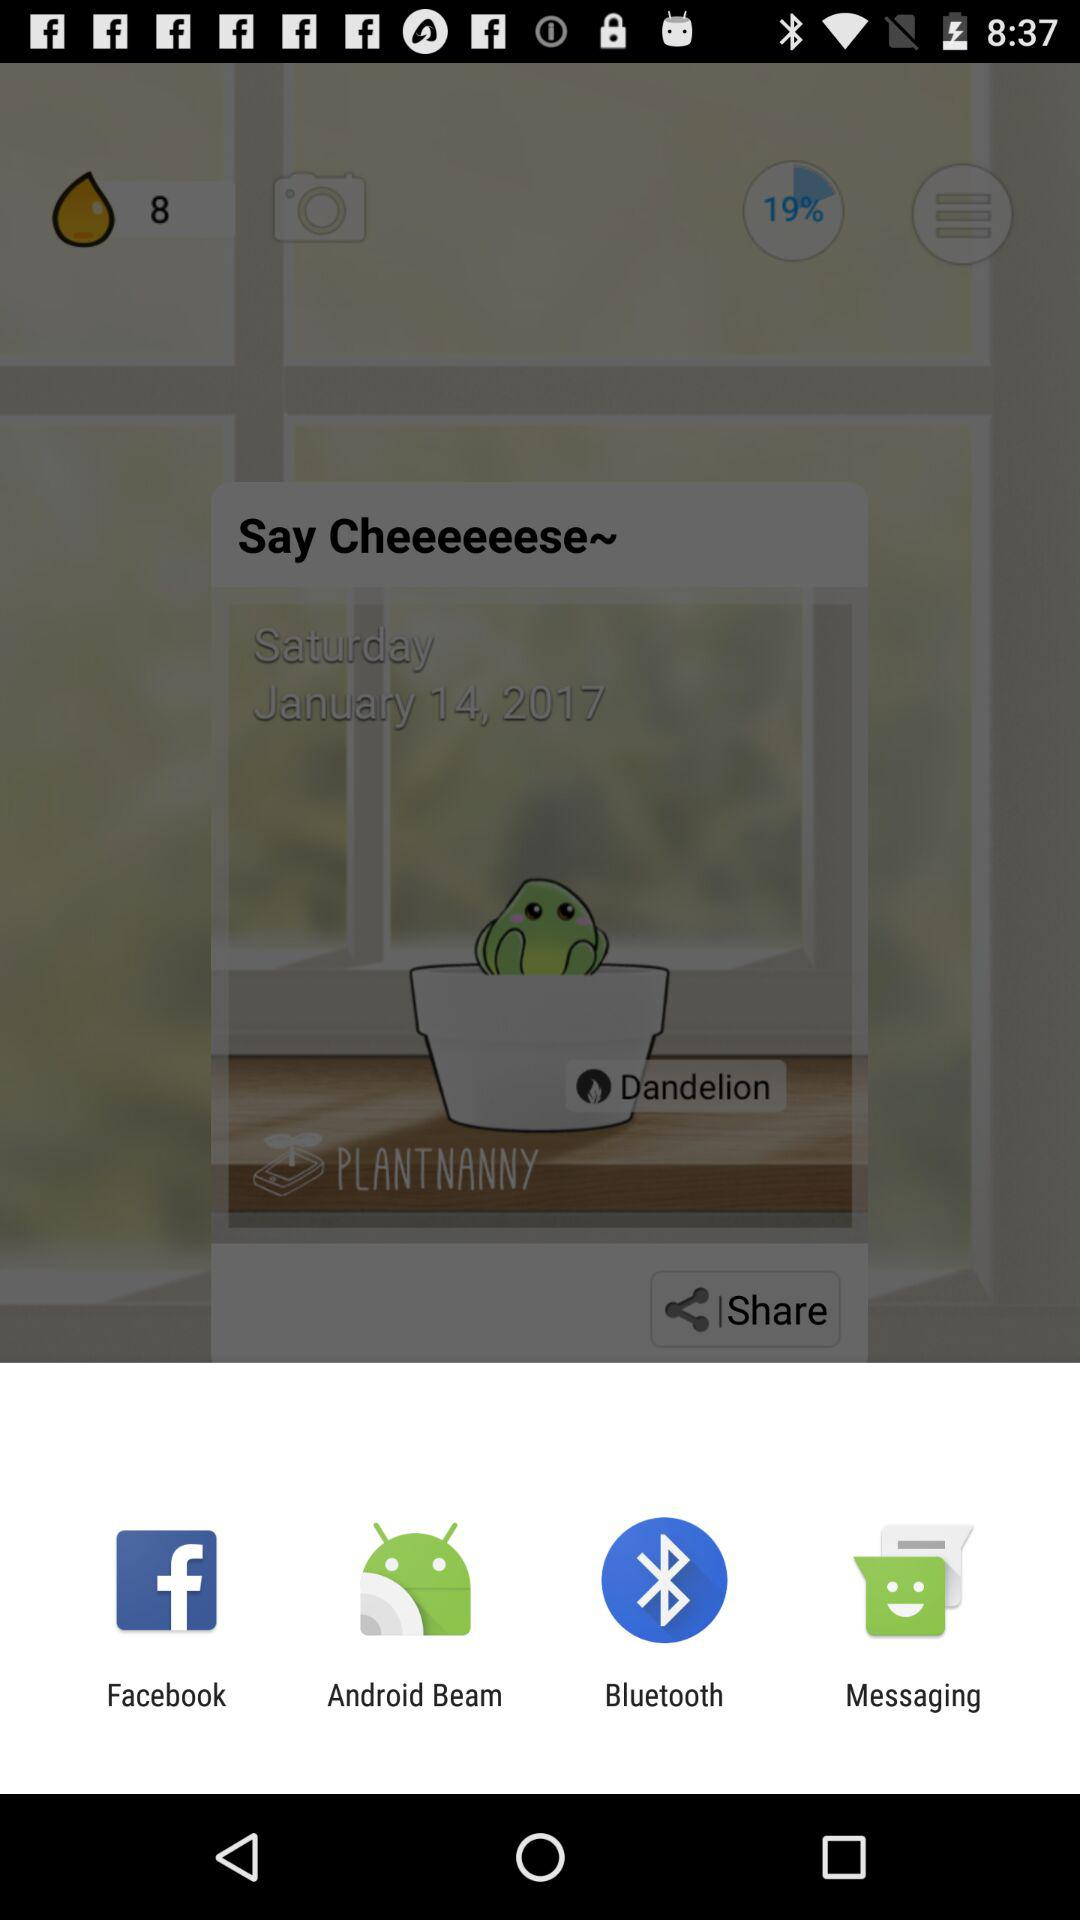What are the different share options? The different share options are "Facebook", "Android Beam", "Bluetooth", and "Messaging". 